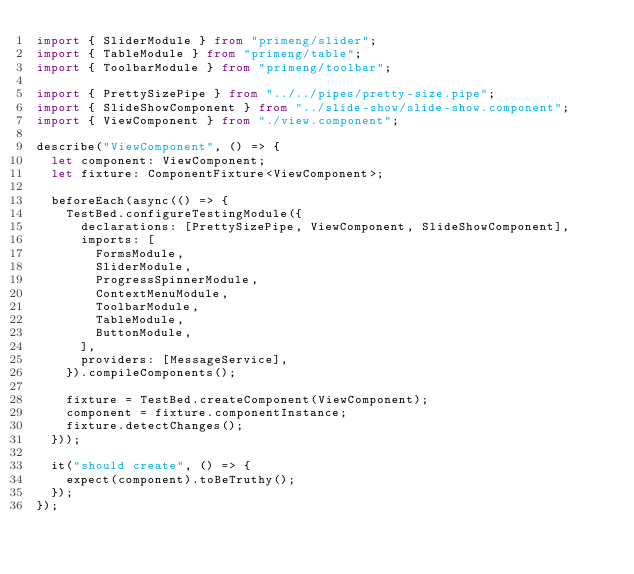Convert code to text. <code><loc_0><loc_0><loc_500><loc_500><_TypeScript_>import { SliderModule } from "primeng/slider";
import { TableModule } from "primeng/table";
import { ToolbarModule } from "primeng/toolbar";

import { PrettySizePipe } from "../../pipes/pretty-size.pipe";
import { SlideShowComponent } from "../slide-show/slide-show.component";
import { ViewComponent } from "./view.component";

describe("ViewComponent", () => {
  let component: ViewComponent;
  let fixture: ComponentFixture<ViewComponent>;

  beforeEach(async(() => {
    TestBed.configureTestingModule({
      declarations: [PrettySizePipe, ViewComponent, SlideShowComponent],
      imports: [
        FormsModule,
        SliderModule,
        ProgressSpinnerModule,
        ContextMenuModule,
        ToolbarModule,
        TableModule,
        ButtonModule,
      ],
      providers: [MessageService],
    }).compileComponents();

    fixture = TestBed.createComponent(ViewComponent);
    component = fixture.componentInstance;
    fixture.detectChanges();
  }));

  it("should create", () => {
    expect(component).toBeTruthy();
  });
});
</code> 